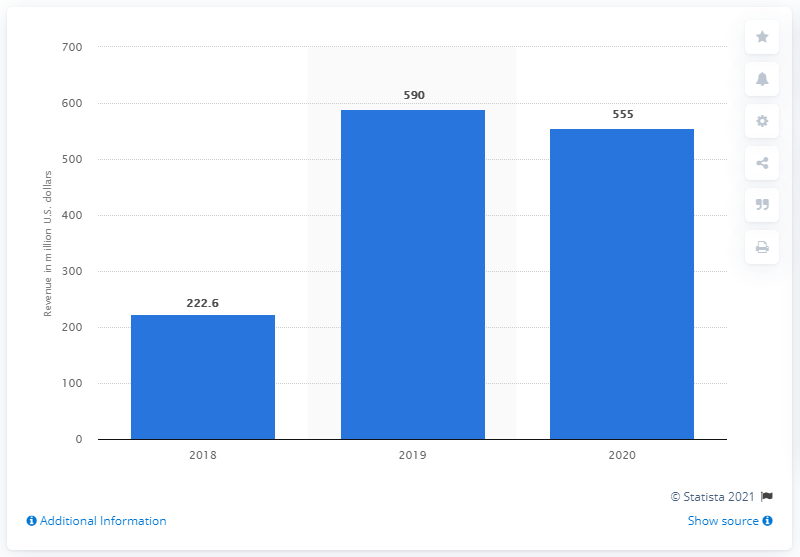Give some essential details in this illustration. In 2018 and 2019, the worldwide revenue of Jimmy Choo averaged 406.3 million USD. Jimmy Choo's global revenue in fiscal year 2020 was approximately 555.. In 2019, Jimmy Choo generated approximately $590 million in revenue. In 2018, Jimmy Choo's worldwide revenue was 222.6 million dollars. 